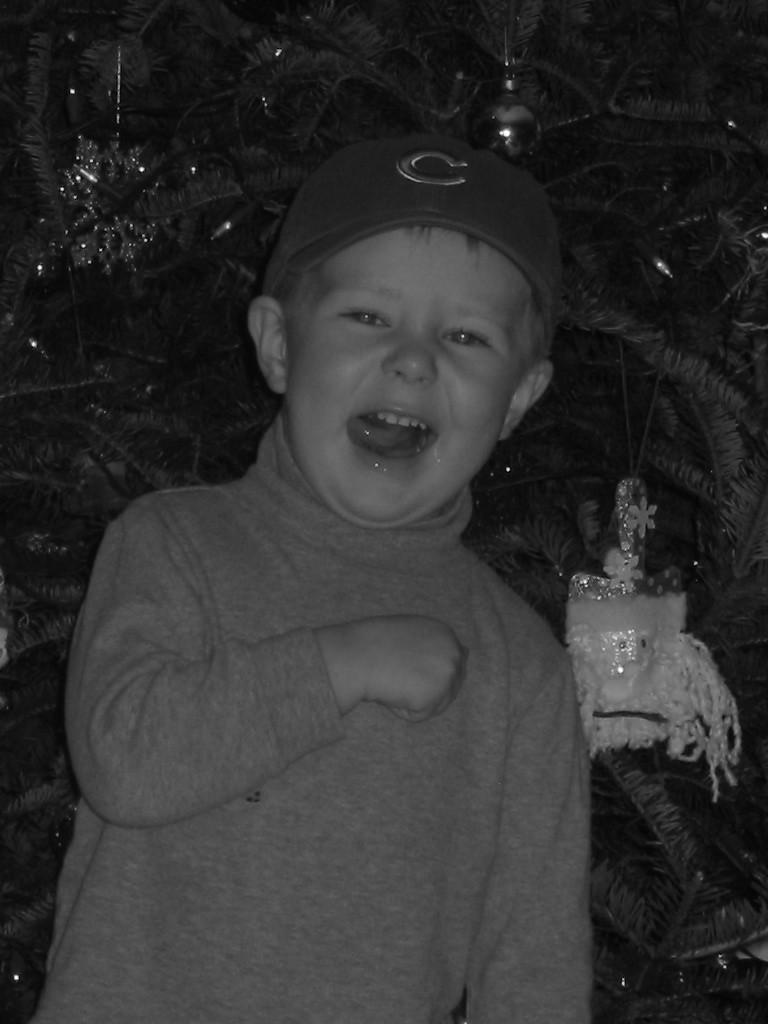What is the main subject of the image? The main subject of the image is a kid. What is the kid wearing in the image? The kid is wearing clothes and a cap. What can be seen in the background of the image? There is a tree in the background of the image. How does the kid maintain balance on the tree in the image? There is no tree present in the image for the kid to maintain balance on. What type of beef is being cooked in the image? There is no beef or any cooking activity present in the image. 